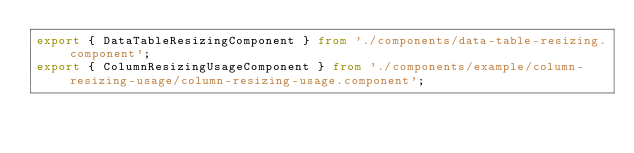Convert code to text. <code><loc_0><loc_0><loc_500><loc_500><_TypeScript_>export { DataTableResizingComponent } from './components/data-table-resizing.component';
export { ColumnResizingUsageComponent } from './components/example/column-resizing-usage/column-resizing-usage.component';
</code> 